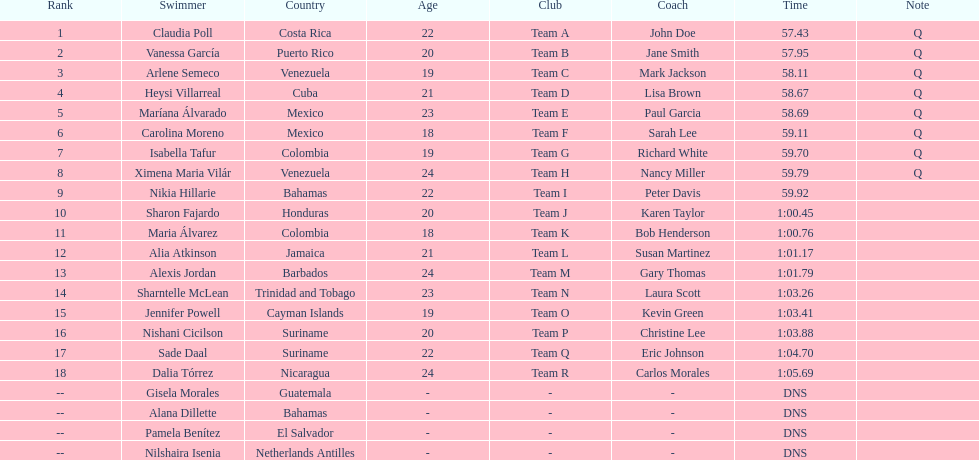Who was the only cuban to finish in the top eight? Heysi Villarreal. 